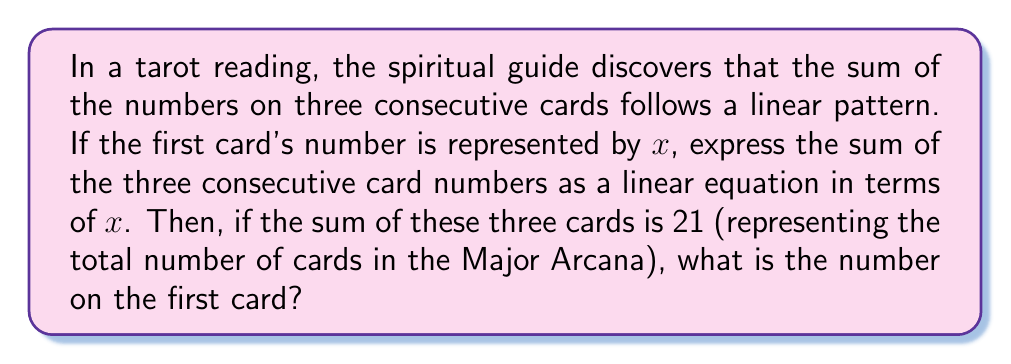Can you answer this question? Let's approach this step-by-step:

1) Let $x$ represent the number on the first card.
2) The second card would then be represented by $x+1$.
3) The third card would be represented by $x+2$.

4) The sum of these three consecutive cards can be expressed as:
   $$S = x + (x+1) + (x+2)$$

5) Simplify the right side of the equation:
   $$S = x + x + 1 + x + 2$$
   $$S = 3x + 3$$

6) This is our linear equation representing the sum of three consecutive tarot card numbers.

7) We're told that the sum equals 21 (the number of Major Arcana cards). So we can set up the equation:
   $$21 = 3x + 3$$

8) Solve for $x$:
   $$21 - 3 = 3x$$
   $$18 = 3x$$
   $$x = 6$$

Therefore, the number on the first card is 6.
Answer: 6 